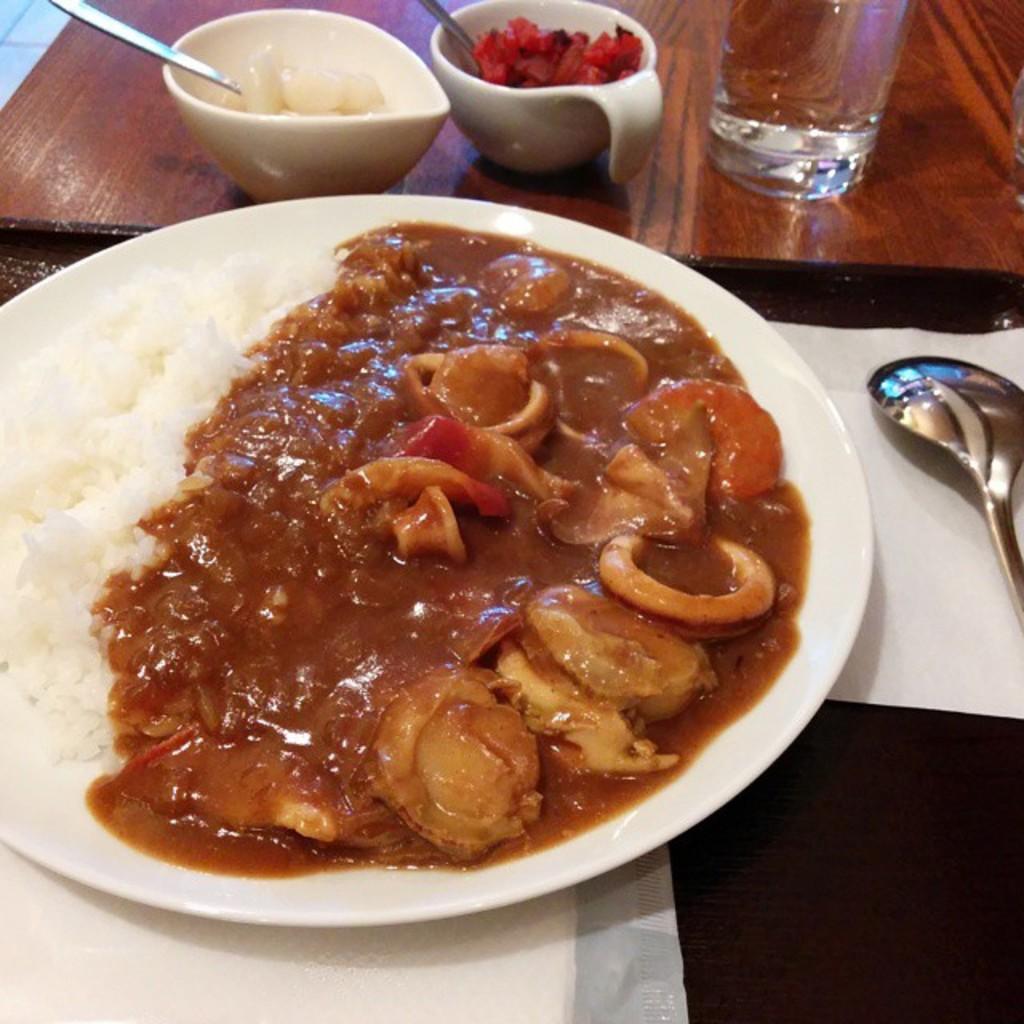Could you give a brief overview of what you see in this image? In this picture, we can see table and some objects on the table like food items served in a plate, bowls, and we can see spoons, glass, and tissue papers. 